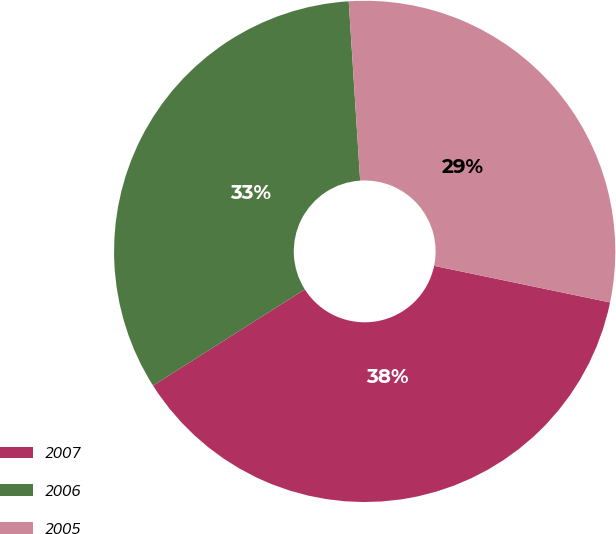Convert chart to OTSL. <chart><loc_0><loc_0><loc_500><loc_500><pie_chart><fcel>2007<fcel>2006<fcel>2005<nl><fcel>37.74%<fcel>32.98%<fcel>29.28%<nl></chart> 